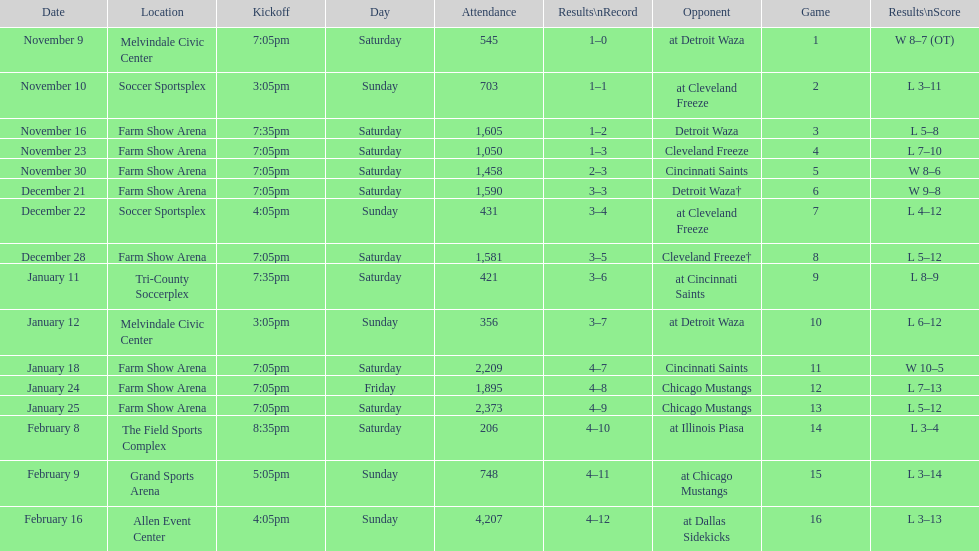Who was the first opponent on this list? Detroit Waza. 